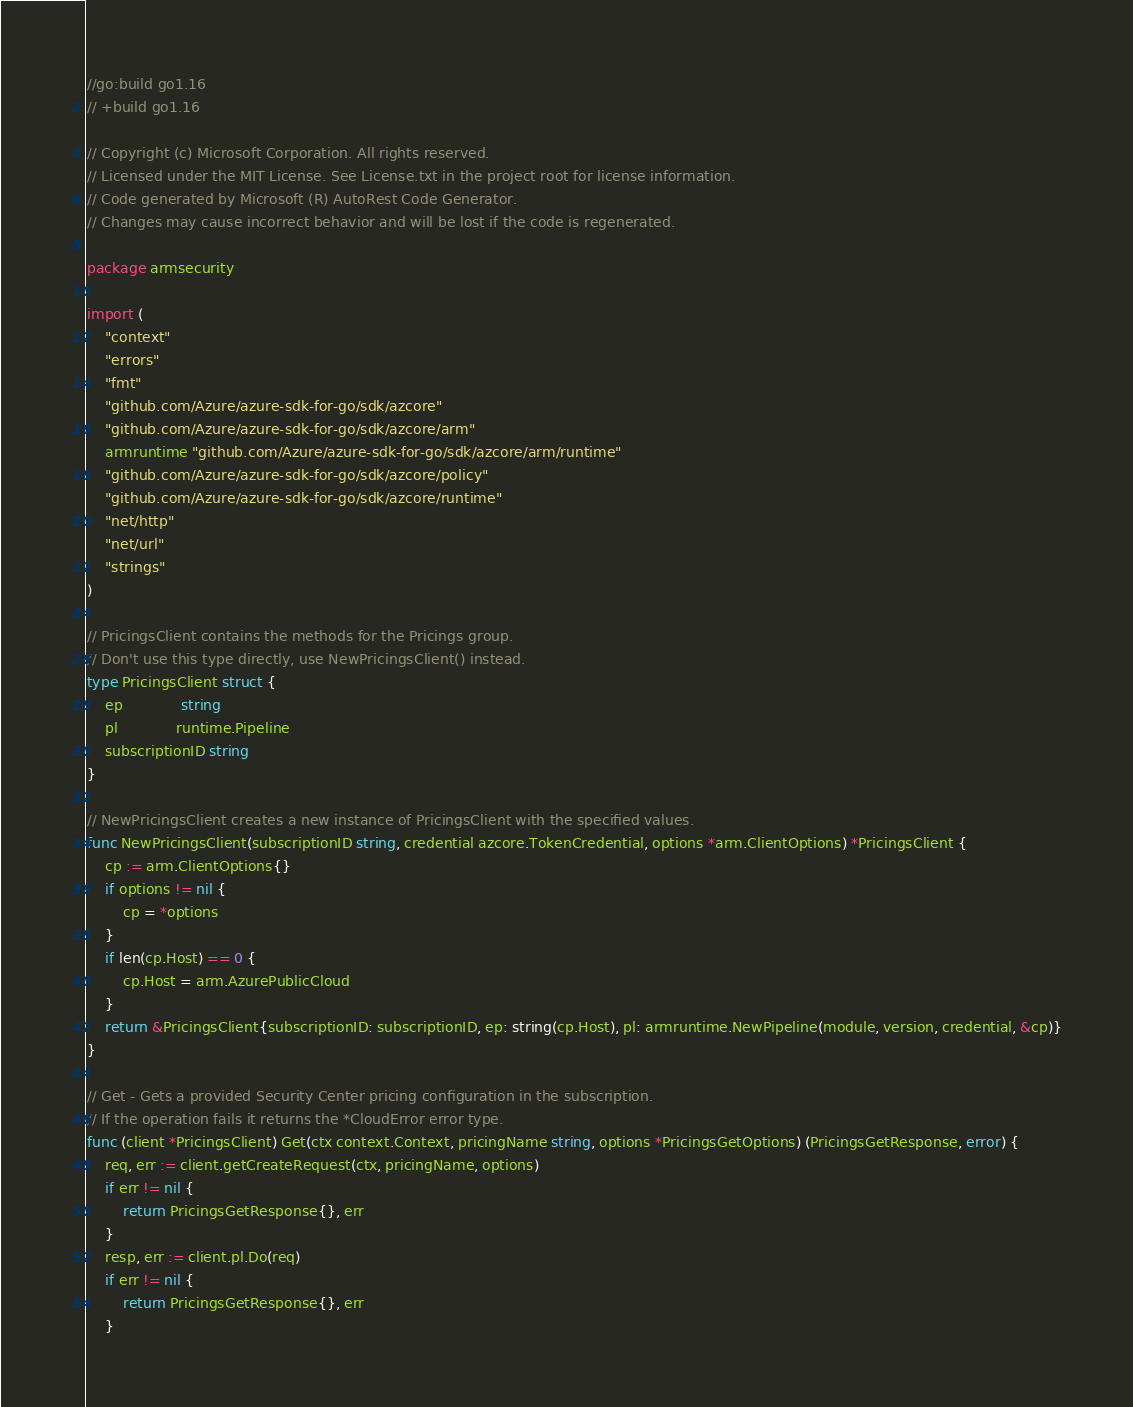Convert code to text. <code><loc_0><loc_0><loc_500><loc_500><_Go_>//go:build go1.16
// +build go1.16

// Copyright (c) Microsoft Corporation. All rights reserved.
// Licensed under the MIT License. See License.txt in the project root for license information.
// Code generated by Microsoft (R) AutoRest Code Generator.
// Changes may cause incorrect behavior and will be lost if the code is regenerated.

package armsecurity

import (
	"context"
	"errors"
	"fmt"
	"github.com/Azure/azure-sdk-for-go/sdk/azcore"
	"github.com/Azure/azure-sdk-for-go/sdk/azcore/arm"
	armruntime "github.com/Azure/azure-sdk-for-go/sdk/azcore/arm/runtime"
	"github.com/Azure/azure-sdk-for-go/sdk/azcore/policy"
	"github.com/Azure/azure-sdk-for-go/sdk/azcore/runtime"
	"net/http"
	"net/url"
	"strings"
)

// PricingsClient contains the methods for the Pricings group.
// Don't use this type directly, use NewPricingsClient() instead.
type PricingsClient struct {
	ep             string
	pl             runtime.Pipeline
	subscriptionID string
}

// NewPricingsClient creates a new instance of PricingsClient with the specified values.
func NewPricingsClient(subscriptionID string, credential azcore.TokenCredential, options *arm.ClientOptions) *PricingsClient {
	cp := arm.ClientOptions{}
	if options != nil {
		cp = *options
	}
	if len(cp.Host) == 0 {
		cp.Host = arm.AzurePublicCloud
	}
	return &PricingsClient{subscriptionID: subscriptionID, ep: string(cp.Host), pl: armruntime.NewPipeline(module, version, credential, &cp)}
}

// Get - Gets a provided Security Center pricing configuration in the subscription.
// If the operation fails it returns the *CloudError error type.
func (client *PricingsClient) Get(ctx context.Context, pricingName string, options *PricingsGetOptions) (PricingsGetResponse, error) {
	req, err := client.getCreateRequest(ctx, pricingName, options)
	if err != nil {
		return PricingsGetResponse{}, err
	}
	resp, err := client.pl.Do(req)
	if err != nil {
		return PricingsGetResponse{}, err
	}</code> 